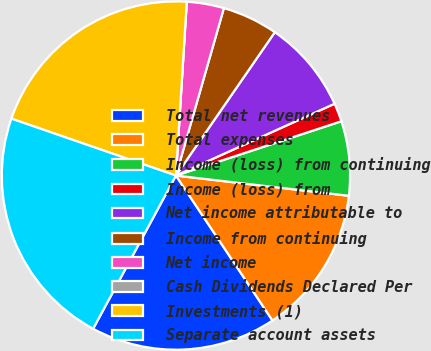Convert chart. <chart><loc_0><loc_0><loc_500><loc_500><pie_chart><fcel>Total net revenues<fcel>Total expenses<fcel>Income (loss) from continuing<fcel>Income (loss) from<fcel>Net income attributable to<fcel>Income from continuing<fcel>Net income<fcel>Cash Dividends Declared Per<fcel>Investments (1)<fcel>Separate account assets<nl><fcel>17.24%<fcel>13.79%<fcel>6.9%<fcel>1.72%<fcel>8.62%<fcel>5.17%<fcel>3.45%<fcel>0.0%<fcel>20.69%<fcel>22.41%<nl></chart> 